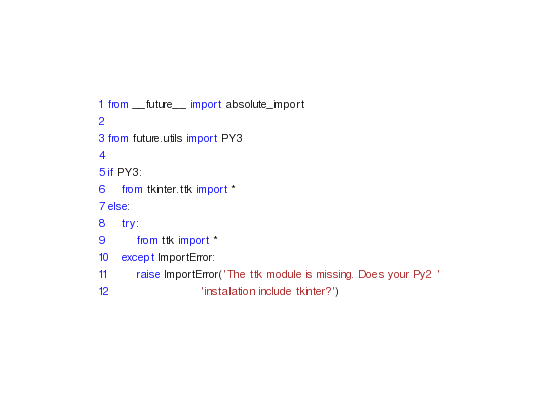<code> <loc_0><loc_0><loc_500><loc_500><_Python_>from __future__ import absolute_import

from future.utils import PY3

if PY3:
    from tkinter.ttk import *
else:
    try:
        from ttk import *
    except ImportError:
        raise ImportError('The ttk module is missing. Does your Py2 '
                          'installation include tkinter?')
</code> 